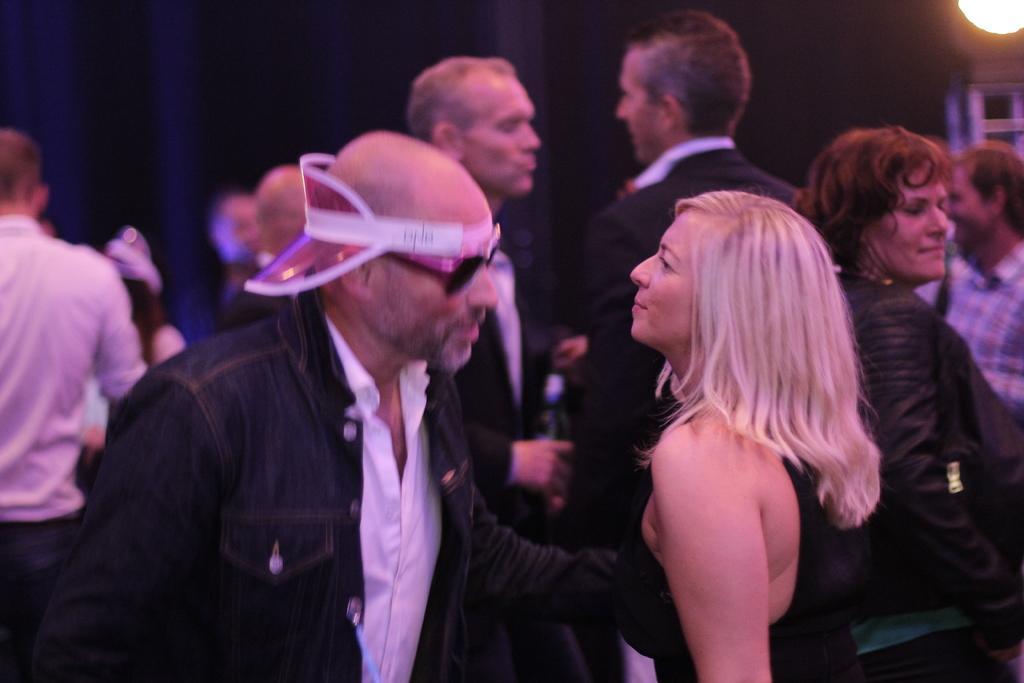Can you describe this image briefly? In this image there are few people dancing inside the room and a light to the pole. 